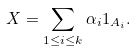<formula> <loc_0><loc_0><loc_500><loc_500>X = \sum _ { 1 \leq i \leq k } \alpha _ { i } 1 _ { A _ { i } } .</formula> 